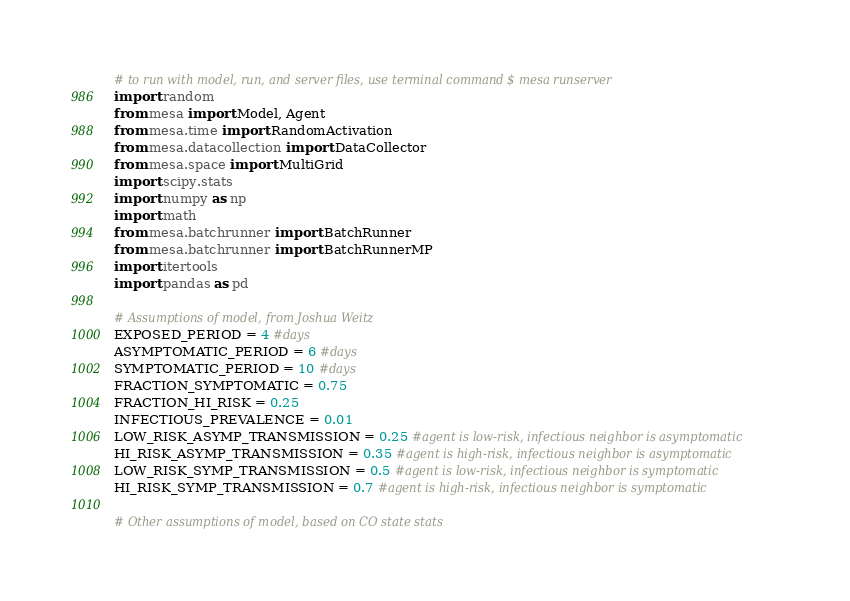Convert code to text. <code><loc_0><loc_0><loc_500><loc_500><_Python_># to run with model, run, and server files, use terminal command $ mesa runserver
import random
from mesa import Model, Agent
from mesa.time import RandomActivation
from mesa.datacollection import DataCollector
from mesa.space import MultiGrid
import scipy.stats
import numpy as np
import math
from mesa.batchrunner import BatchRunner
from mesa.batchrunner import BatchRunnerMP
import itertools
import pandas as pd

# Assumptions of model, from Joshua Weitz
EXPOSED_PERIOD = 4 #days
ASYMPTOMATIC_PERIOD = 6 #days
SYMPTOMATIC_PERIOD = 10 #days
FRACTION_SYMPTOMATIC = 0.75
FRACTION_HI_RISK = 0.25
INFECTIOUS_PREVALENCE = 0.01
LOW_RISK_ASYMP_TRANSMISSION = 0.25 #agent is low-risk, infectious neighbor is asymptomatic
HI_RISK_ASYMP_TRANSMISSION = 0.35 #agent is high-risk, infectious neighbor is asymptomatic
LOW_RISK_SYMP_TRANSMISSION = 0.5 #agent is low-risk, infectious neighbor is symptomatic
HI_RISK_SYMP_TRANSMISSION = 0.7 #agent is high-risk, infectious neighbor is symptomatic

# Other assumptions of model, based on CO state stats</code> 